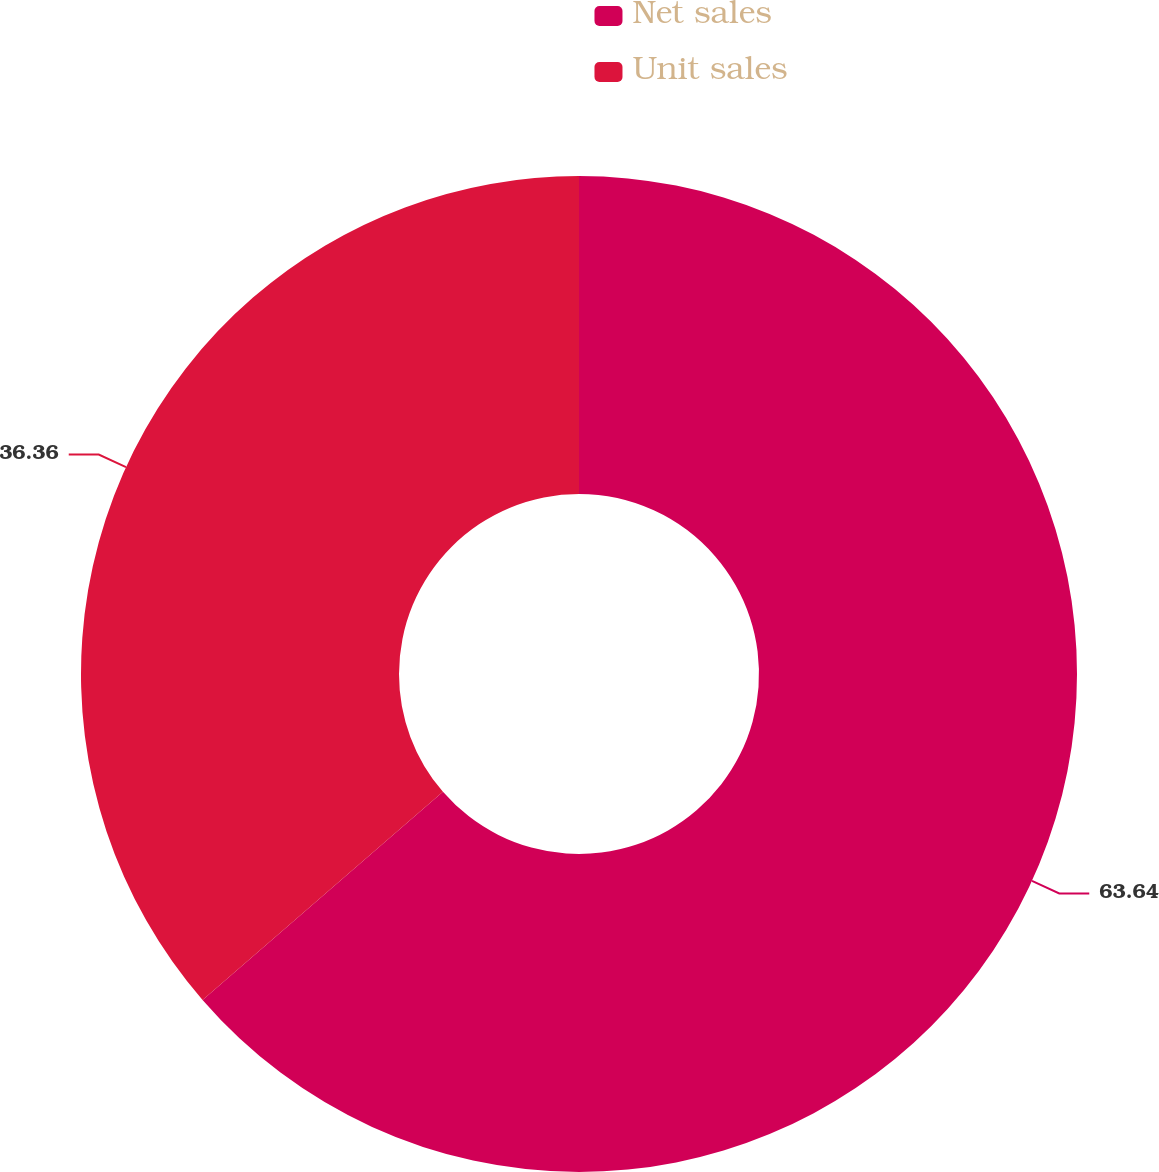Convert chart to OTSL. <chart><loc_0><loc_0><loc_500><loc_500><pie_chart><fcel>Net sales<fcel>Unit sales<nl><fcel>63.64%<fcel>36.36%<nl></chart> 